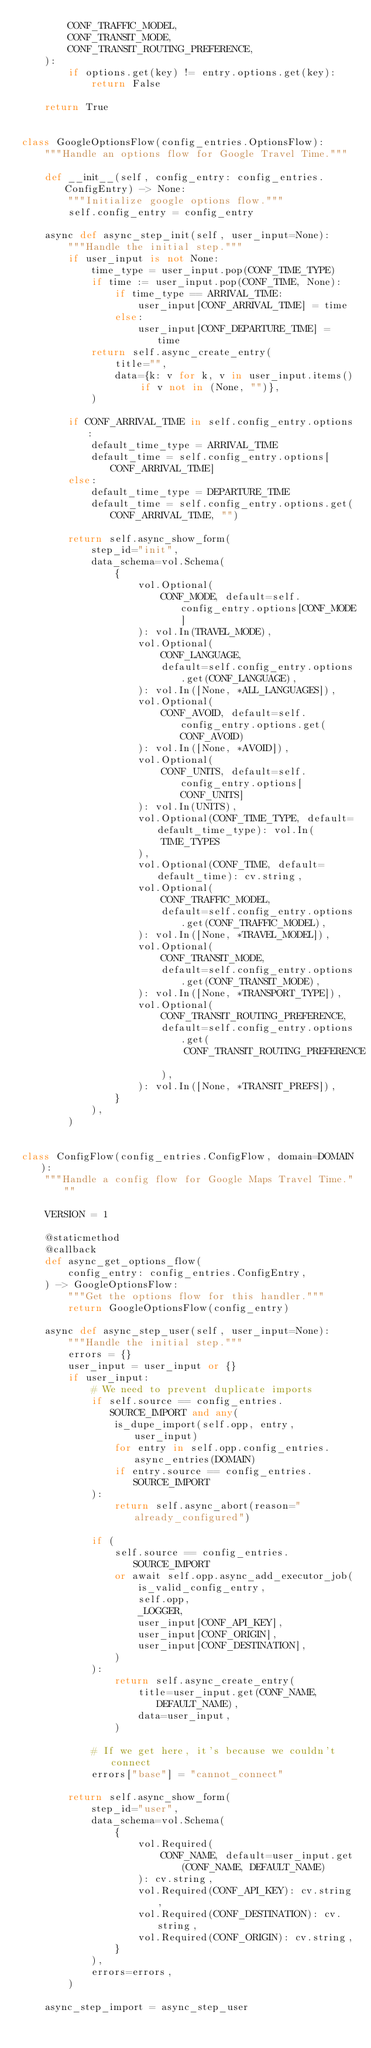<code> <loc_0><loc_0><loc_500><loc_500><_Python_>        CONF_TRAFFIC_MODEL,
        CONF_TRANSIT_MODE,
        CONF_TRANSIT_ROUTING_PREFERENCE,
    ):
        if options.get(key) != entry.options.get(key):
            return False

    return True


class GoogleOptionsFlow(config_entries.OptionsFlow):
    """Handle an options flow for Google Travel Time."""

    def __init__(self, config_entry: config_entries.ConfigEntry) -> None:
        """Initialize google options flow."""
        self.config_entry = config_entry

    async def async_step_init(self, user_input=None):
        """Handle the initial step."""
        if user_input is not None:
            time_type = user_input.pop(CONF_TIME_TYPE)
            if time := user_input.pop(CONF_TIME, None):
                if time_type == ARRIVAL_TIME:
                    user_input[CONF_ARRIVAL_TIME] = time
                else:
                    user_input[CONF_DEPARTURE_TIME] = time
            return self.async_create_entry(
                title="",
                data={k: v for k, v in user_input.items() if v not in (None, "")},
            )

        if CONF_ARRIVAL_TIME in self.config_entry.options:
            default_time_type = ARRIVAL_TIME
            default_time = self.config_entry.options[CONF_ARRIVAL_TIME]
        else:
            default_time_type = DEPARTURE_TIME
            default_time = self.config_entry.options.get(CONF_ARRIVAL_TIME, "")

        return self.async_show_form(
            step_id="init",
            data_schema=vol.Schema(
                {
                    vol.Optional(
                        CONF_MODE, default=self.config_entry.options[CONF_MODE]
                    ): vol.In(TRAVEL_MODE),
                    vol.Optional(
                        CONF_LANGUAGE,
                        default=self.config_entry.options.get(CONF_LANGUAGE),
                    ): vol.In([None, *ALL_LANGUAGES]),
                    vol.Optional(
                        CONF_AVOID, default=self.config_entry.options.get(CONF_AVOID)
                    ): vol.In([None, *AVOID]),
                    vol.Optional(
                        CONF_UNITS, default=self.config_entry.options[CONF_UNITS]
                    ): vol.In(UNITS),
                    vol.Optional(CONF_TIME_TYPE, default=default_time_type): vol.In(
                        TIME_TYPES
                    ),
                    vol.Optional(CONF_TIME, default=default_time): cv.string,
                    vol.Optional(
                        CONF_TRAFFIC_MODEL,
                        default=self.config_entry.options.get(CONF_TRAFFIC_MODEL),
                    ): vol.In([None, *TRAVEL_MODEL]),
                    vol.Optional(
                        CONF_TRANSIT_MODE,
                        default=self.config_entry.options.get(CONF_TRANSIT_MODE),
                    ): vol.In([None, *TRANSPORT_TYPE]),
                    vol.Optional(
                        CONF_TRANSIT_ROUTING_PREFERENCE,
                        default=self.config_entry.options.get(
                            CONF_TRANSIT_ROUTING_PREFERENCE
                        ),
                    ): vol.In([None, *TRANSIT_PREFS]),
                }
            ),
        )


class ConfigFlow(config_entries.ConfigFlow, domain=DOMAIN):
    """Handle a config flow for Google Maps Travel Time."""

    VERSION = 1

    @staticmethod
    @callback
    def async_get_options_flow(
        config_entry: config_entries.ConfigEntry,
    ) -> GoogleOptionsFlow:
        """Get the options flow for this handler."""
        return GoogleOptionsFlow(config_entry)

    async def async_step_user(self, user_input=None):
        """Handle the initial step."""
        errors = {}
        user_input = user_input or {}
        if user_input:
            # We need to prevent duplicate imports
            if self.source == config_entries.SOURCE_IMPORT and any(
                is_dupe_import(self.opp, entry, user_input)
                for entry in self.opp.config_entries.async_entries(DOMAIN)
                if entry.source == config_entries.SOURCE_IMPORT
            ):
                return self.async_abort(reason="already_configured")

            if (
                self.source == config_entries.SOURCE_IMPORT
                or await self.opp.async_add_executor_job(
                    is_valid_config_entry,
                    self.opp,
                    _LOGGER,
                    user_input[CONF_API_KEY],
                    user_input[CONF_ORIGIN],
                    user_input[CONF_DESTINATION],
                )
            ):
                return self.async_create_entry(
                    title=user_input.get(CONF_NAME, DEFAULT_NAME),
                    data=user_input,
                )

            # If we get here, it's because we couldn't connect
            errors["base"] = "cannot_connect"

        return self.async_show_form(
            step_id="user",
            data_schema=vol.Schema(
                {
                    vol.Required(
                        CONF_NAME, default=user_input.get(CONF_NAME, DEFAULT_NAME)
                    ): cv.string,
                    vol.Required(CONF_API_KEY): cv.string,
                    vol.Required(CONF_DESTINATION): cv.string,
                    vol.Required(CONF_ORIGIN): cv.string,
                }
            ),
            errors=errors,
        )

    async_step_import = async_step_user
</code> 